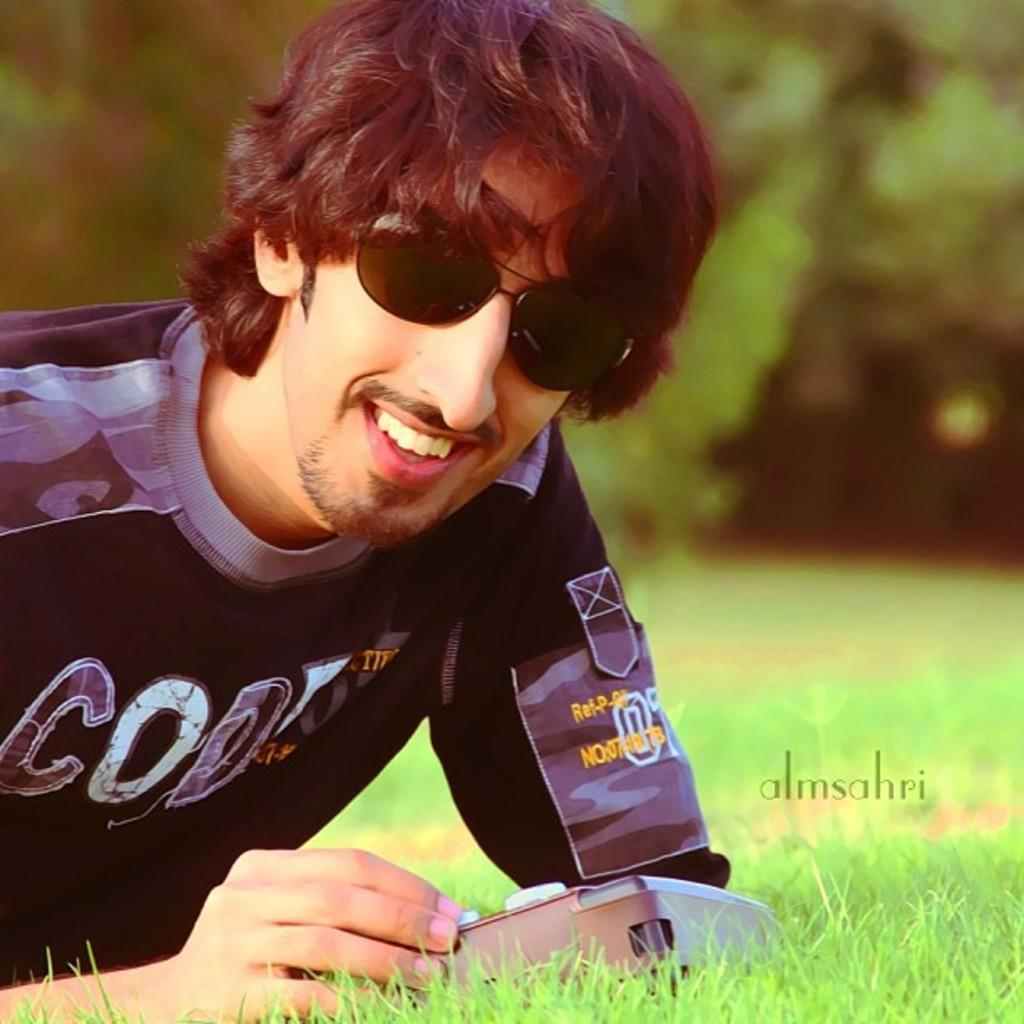What is the main subject of the image? The main subject of the image is a man. What is the man doing in the image? The man is leaning on the grass surface and smiling. What can be seen in the background of the image? There are trees in the background of the image, but they are not clearly visible. What direction is the potato facing in the image? There is no potato present in the image, so it cannot be determined which direction it would be facing. 